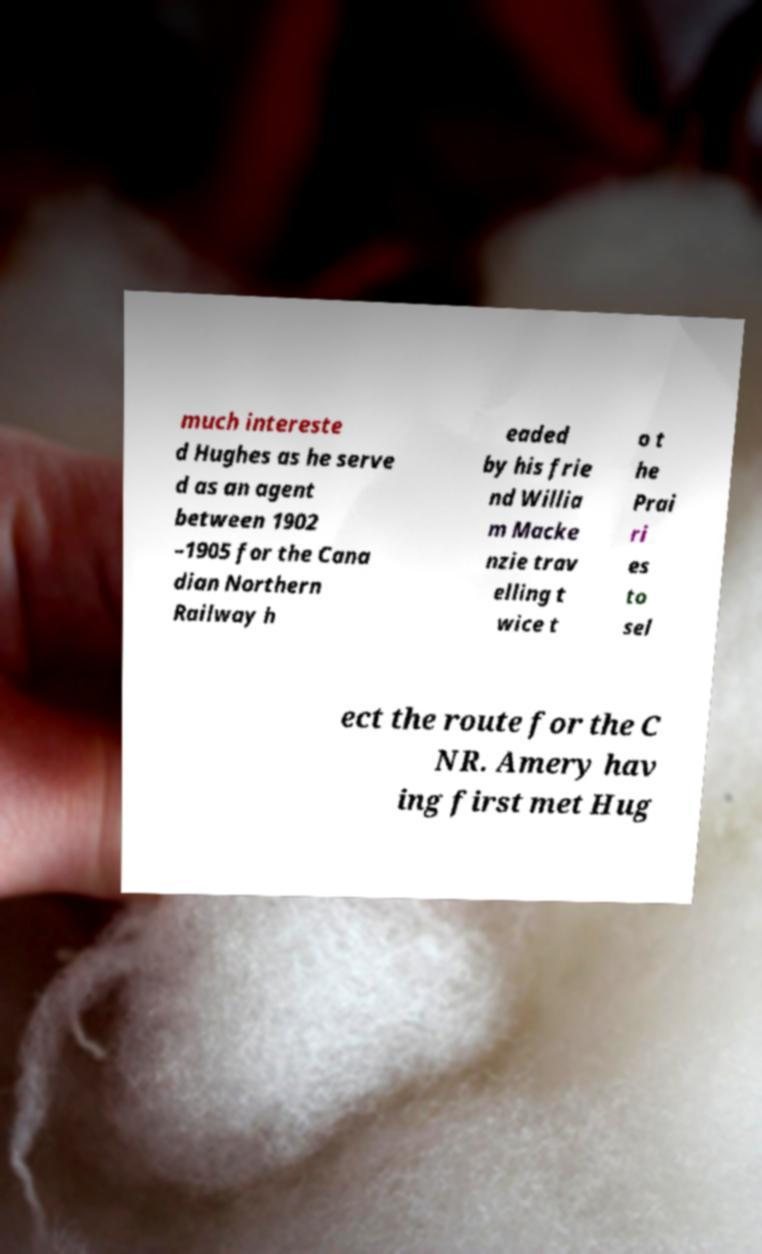For documentation purposes, I need the text within this image transcribed. Could you provide that? much intereste d Hughes as he serve d as an agent between 1902 –1905 for the Cana dian Northern Railway h eaded by his frie nd Willia m Macke nzie trav elling t wice t o t he Prai ri es to sel ect the route for the C NR. Amery hav ing first met Hug 